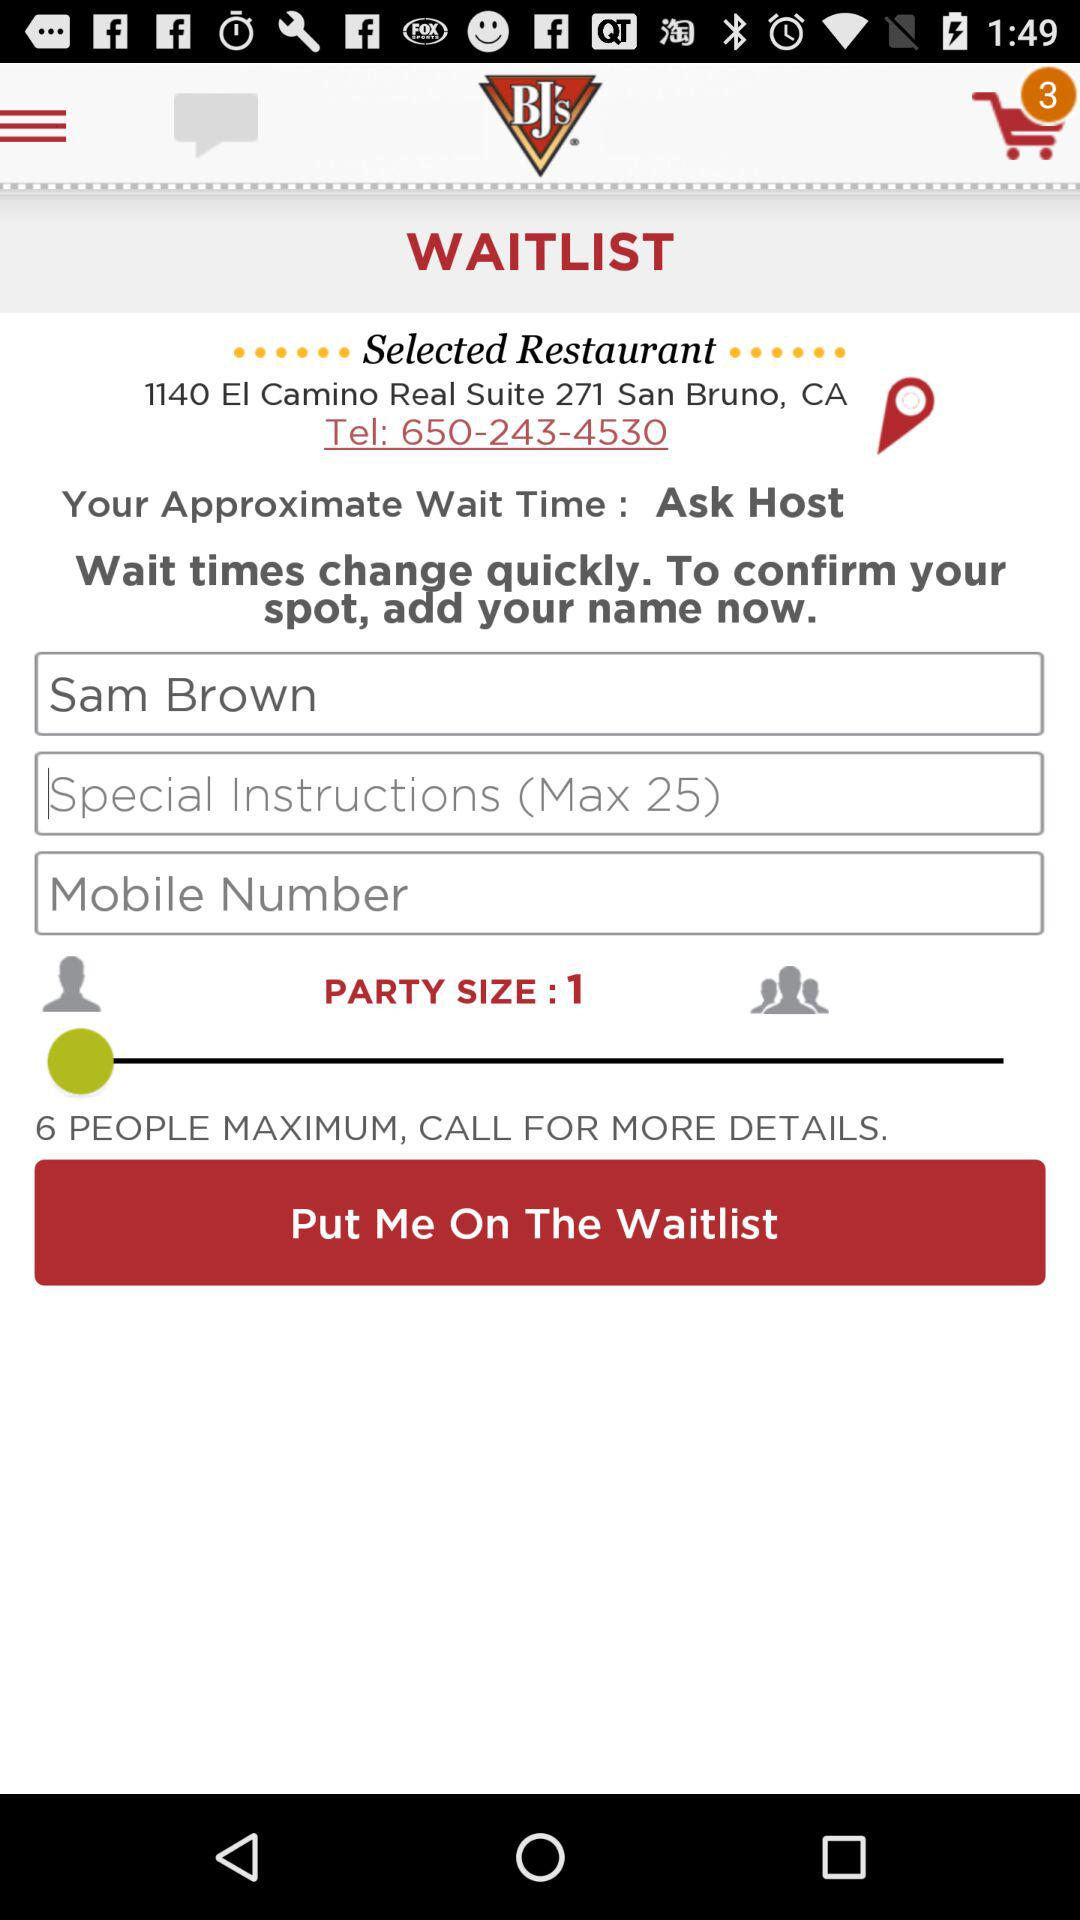What is the name of the person on "WAITLIST"? The name of the person is Sam Brown. 